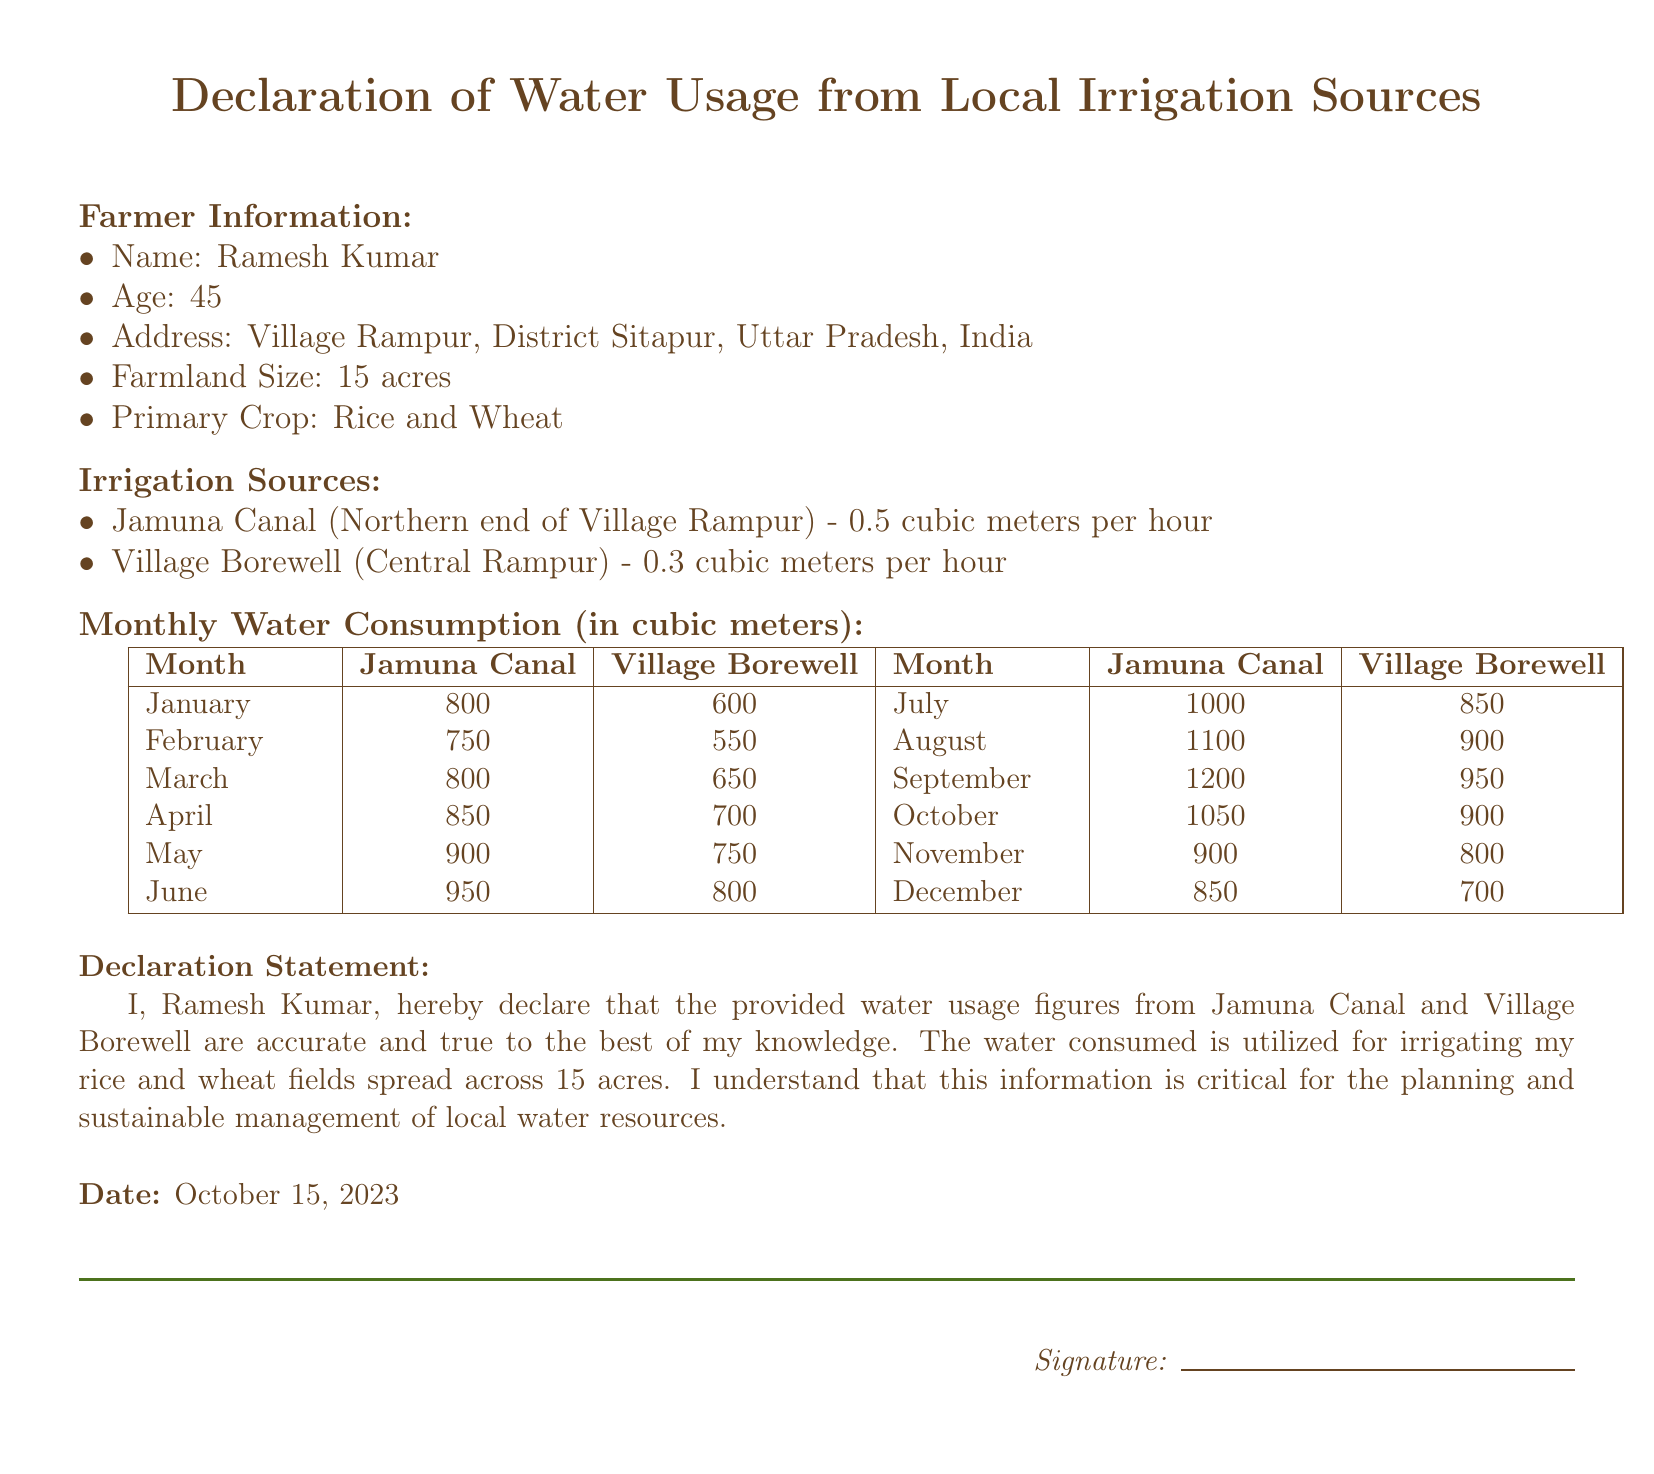What is the name of the farmer? The name of the farmer is explicitly stated in the document.
Answer: Ramesh Kumar What is the age of Ramesh Kumar? The age of Ramesh Kumar is mentioned in the farmer information section.
Answer: 45 How many acres of farmland does Ramesh have? The document specifies the size of Ramesh’s farmland in acres.
Answer: 15 acres Which irrigation source has a higher monthly consumption in July? The document provides a comparison of the monthly water consumption for each source.
Answer: Jamuna Canal What is the monthly water consumption from the Village Borewell in October? The document includes detailed monthly water usage figures, including for October.
Answer: 900 In which month does the consumption from the Jamuna Canal reach its peak? Analyzing the monthly figures, the month with the highest usage for Jamuna Canal can be determined.
Answer: September What is the total water consumption from both sources in May? Adding the water consumption figures from both sources in May gives the total for that month.
Answer: 1650 What declaration does Ramesh Kumar make regarding the figures? The declaration statement highlights the commitment to the accuracy of the water usage figures.
Answer: Accurate and true What crops does Ramesh Kumar primarily cultivate? The primary crops are indicated in the farmer information section of the document.
Answer: Rice and Wheat 